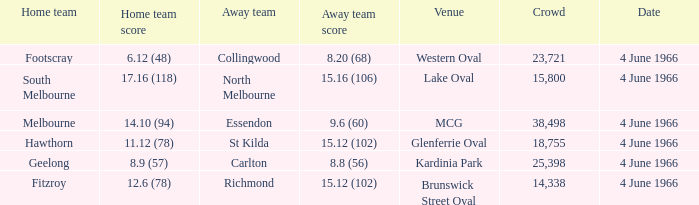What is the average crowd size of the away team who scored 9.6 (60)? 38498.0. 